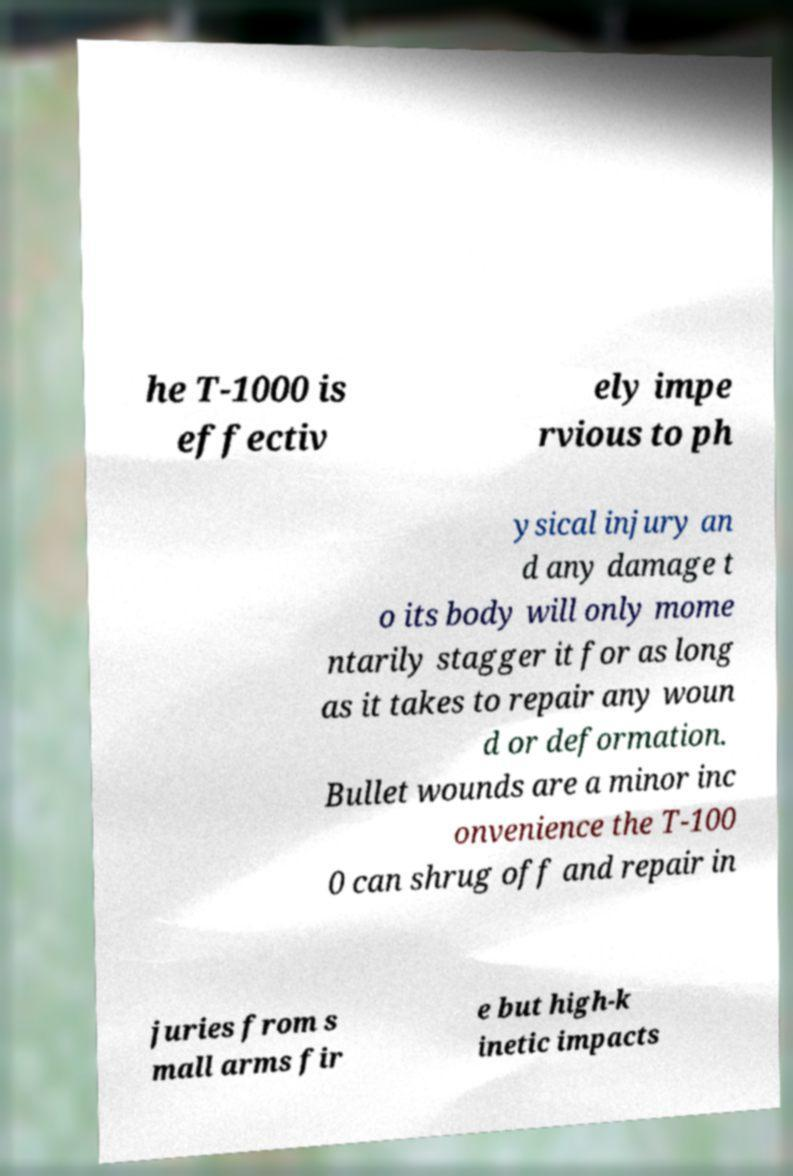Can you accurately transcribe the text from the provided image for me? he T-1000 is effectiv ely impe rvious to ph ysical injury an d any damage t o its body will only mome ntarily stagger it for as long as it takes to repair any woun d or deformation. Bullet wounds are a minor inc onvenience the T-100 0 can shrug off and repair in juries from s mall arms fir e but high-k inetic impacts 